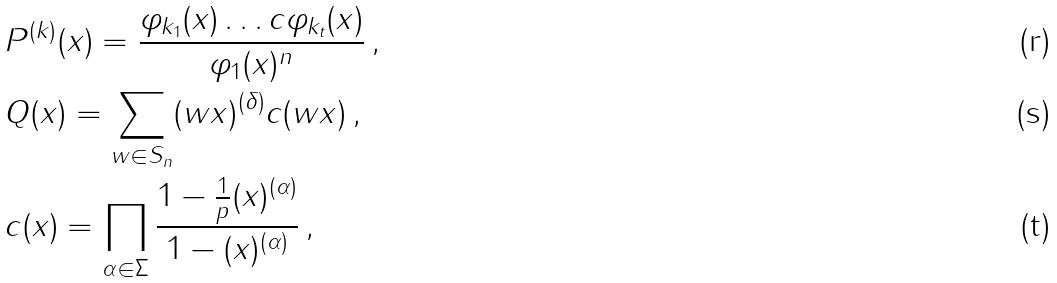Convert formula to latex. <formula><loc_0><loc_0><loc_500><loc_500>& P ^ { ( k ) } ( x ) = \frac { \varphi _ { k _ { 1 } } ( x ) \dots c \varphi _ { k _ { t } } ( x ) } { \varphi _ { 1 } ( x ) ^ { n } } \, , \\ & Q ( x ) = \sum _ { w \in S _ { n } } ( w x ) ^ { ( \delta ) } c ( w x ) \, , \\ & c ( x ) = \prod _ { \alpha \in \Sigma } \frac { 1 - \frac { 1 } { p } ( x ) ^ { ( \alpha ) } } { 1 - ( x ) ^ { ( \alpha ) } } \, ,</formula> 